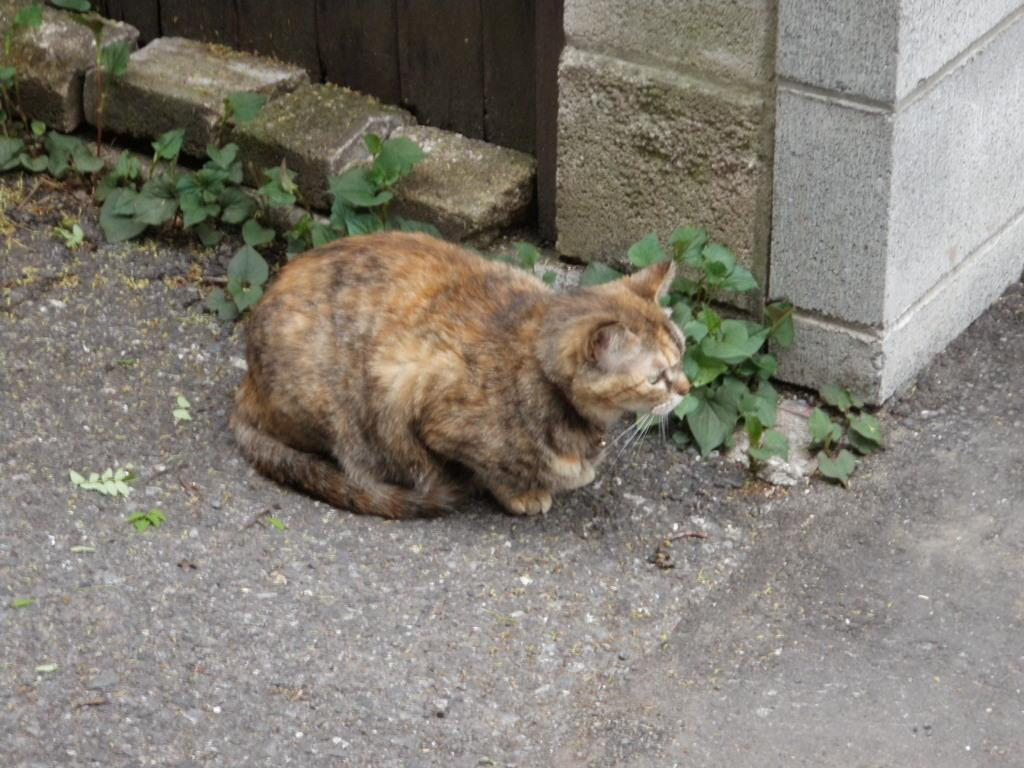What type of animal is present in the image? There is a cat in the image. What other elements can be seen in the image besides the cat? There are plants and bricks visible in the image. What type of cable is being used by the children in the image? There are no children or cables present in the image. What topic are the children talking about in the image? There are no children present in the image, so it is not possible to determine what they might be talking about. 